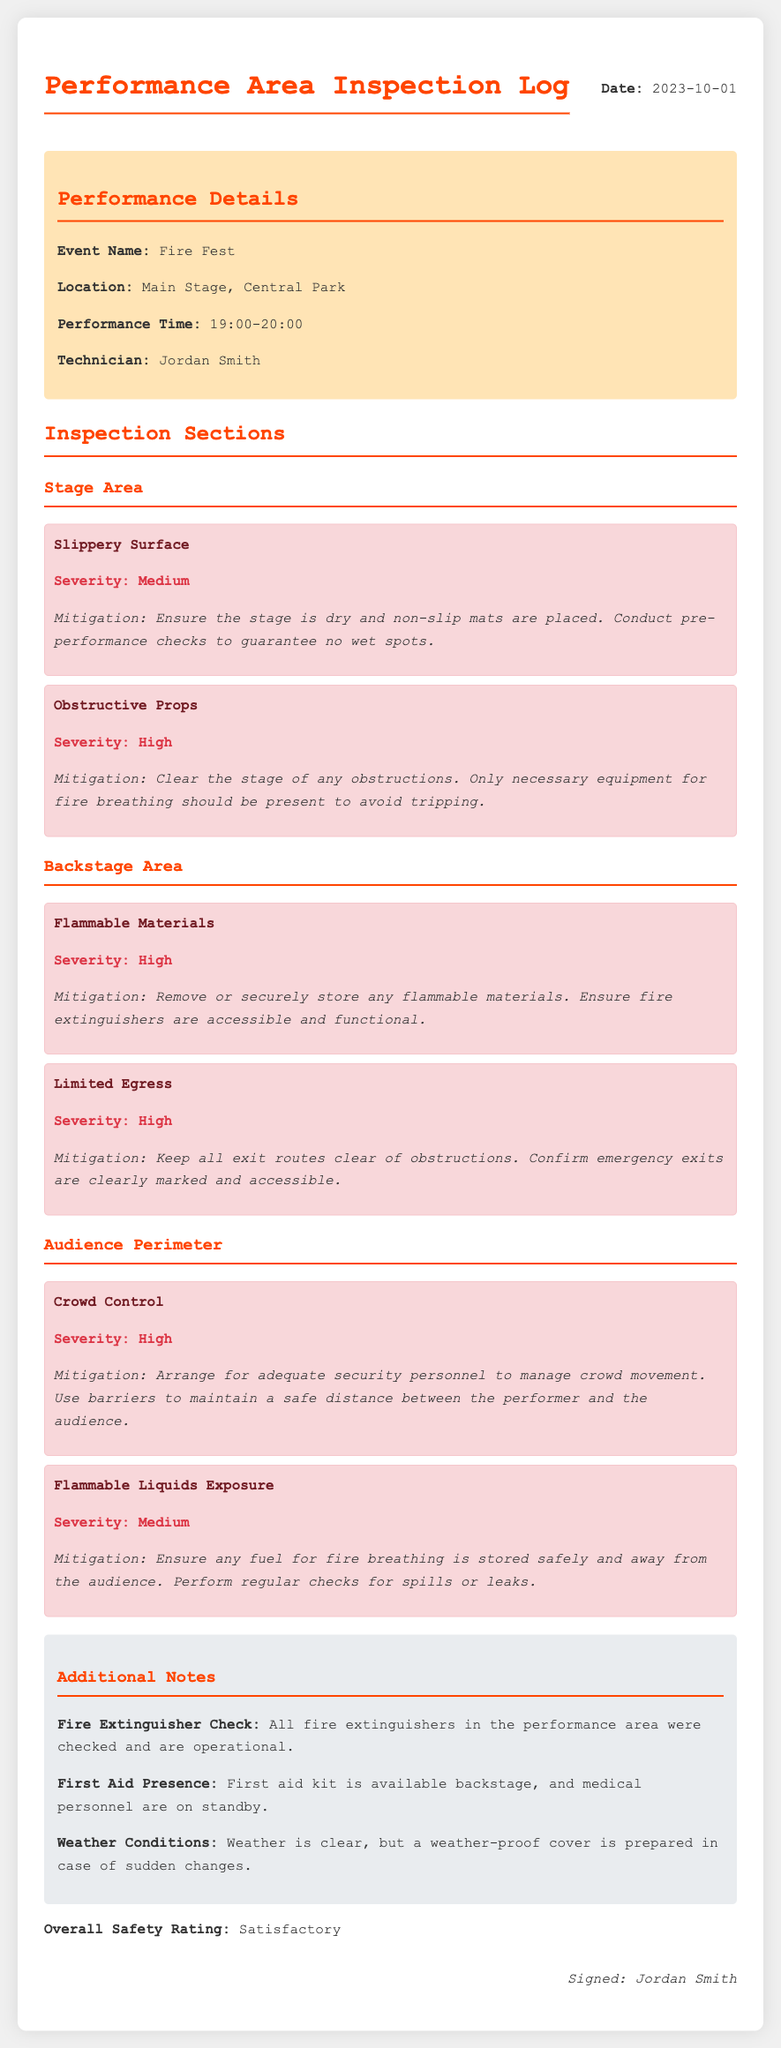what is the date of the inspection? The date of the inspection is mentioned at the top of the document.
Answer: 2023-10-01 who was the technician for this event? The technician is specified in the performance details section of the document.
Answer: Jordan Smith what is the event name? The event name is indicated in the performance details section.
Answer: Fire Fest what is the severity of obstructive props? The severity is noted in the hazard section related to obstructive props.
Answer: High what mitigation step is suggested for slippery surfaces? The mitigation step for slippery surfaces is detailed under the relevant hazard.
Answer: Ensure the stage is dry and non-slip mats are placed how many hazards are mentioned in the backstage area? The backstage area hazards are listed, and the quantity can be counted from the document.
Answer: 2 what is recommended for crowd control? The recommendation for crowd control is found in the audience perimeter hazard section.
Answer: Arrange for adequate security personnel what should be done with flammable materials? The actions regarding flammable materials are specified in the backstage hazards section.
Answer: Remove or securely store any flammable materials what is the overall safety rating? The overall safety rating is presented at the end of the document.
Answer: Satisfactory 